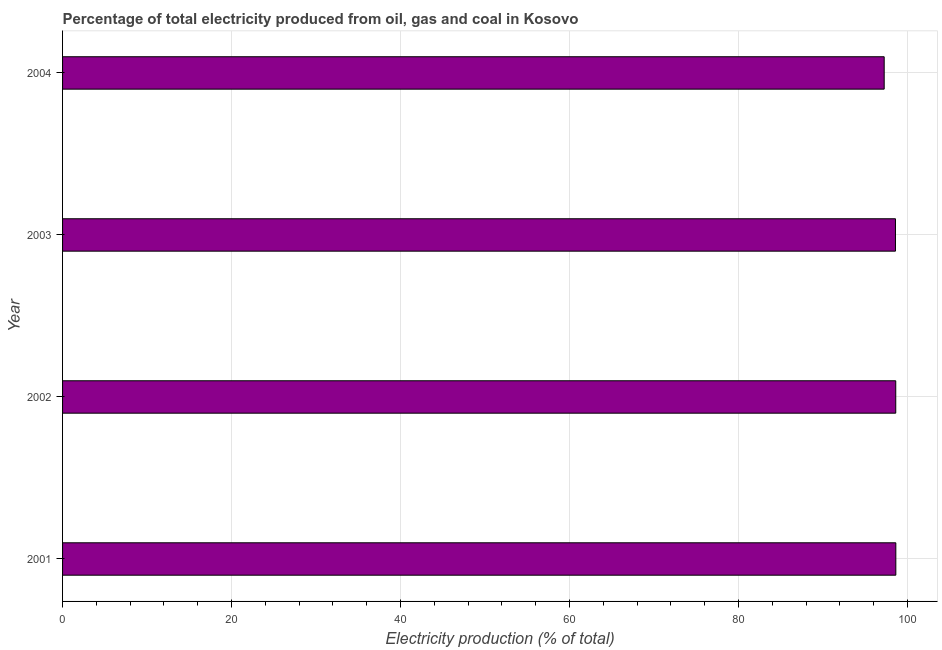Does the graph contain any zero values?
Offer a very short reply. No. Does the graph contain grids?
Provide a succinct answer. Yes. What is the title of the graph?
Make the answer very short. Percentage of total electricity produced from oil, gas and coal in Kosovo. What is the label or title of the X-axis?
Your answer should be compact. Electricity production (% of total). What is the electricity production in 2004?
Provide a succinct answer. 97.23. Across all years, what is the maximum electricity production?
Offer a very short reply. 98.61. Across all years, what is the minimum electricity production?
Offer a very short reply. 97.23. In which year was the electricity production maximum?
Offer a terse response. 2001. What is the sum of the electricity production?
Keep it short and to the point. 393.01. What is the difference between the electricity production in 2001 and 2002?
Your answer should be compact. 0.01. What is the average electricity production per year?
Your answer should be very brief. 98.25. What is the median electricity production?
Provide a short and direct response. 98.58. Do a majority of the years between 2002 and 2004 (inclusive) have electricity production greater than 12 %?
Your answer should be compact. Yes. What is the ratio of the electricity production in 2001 to that in 2003?
Offer a very short reply. 1. Is the electricity production in 2003 less than that in 2004?
Your answer should be very brief. No. Is the difference between the electricity production in 2001 and 2004 greater than the difference between any two years?
Provide a short and direct response. Yes. What is the difference between the highest and the second highest electricity production?
Keep it short and to the point. 0.01. Is the sum of the electricity production in 2003 and 2004 greater than the maximum electricity production across all years?
Give a very brief answer. Yes. What is the difference between the highest and the lowest electricity production?
Offer a terse response. 1.38. In how many years, is the electricity production greater than the average electricity production taken over all years?
Offer a terse response. 3. How many bars are there?
Make the answer very short. 4. Are all the bars in the graph horizontal?
Provide a succinct answer. Yes. What is the Electricity production (% of total) in 2001?
Your response must be concise. 98.61. What is the Electricity production (% of total) of 2002?
Your response must be concise. 98.6. What is the Electricity production (% of total) of 2003?
Offer a very short reply. 98.57. What is the Electricity production (% of total) in 2004?
Provide a succinct answer. 97.23. What is the difference between the Electricity production (% of total) in 2001 and 2002?
Your answer should be very brief. 0.01. What is the difference between the Electricity production (% of total) in 2001 and 2003?
Provide a succinct answer. 0.04. What is the difference between the Electricity production (% of total) in 2001 and 2004?
Provide a succinct answer. 1.38. What is the difference between the Electricity production (% of total) in 2002 and 2003?
Ensure brevity in your answer.  0.03. What is the difference between the Electricity production (% of total) in 2002 and 2004?
Offer a terse response. 1.37. What is the difference between the Electricity production (% of total) in 2003 and 2004?
Give a very brief answer. 1.34. What is the ratio of the Electricity production (% of total) in 2001 to that in 2002?
Provide a short and direct response. 1. What is the ratio of the Electricity production (% of total) in 2001 to that in 2004?
Make the answer very short. 1.01. 